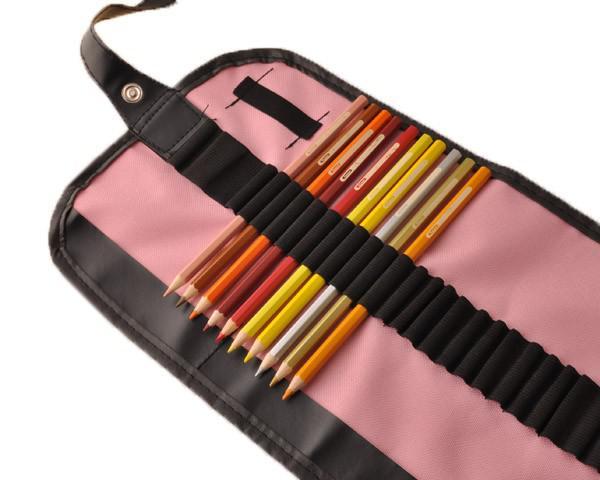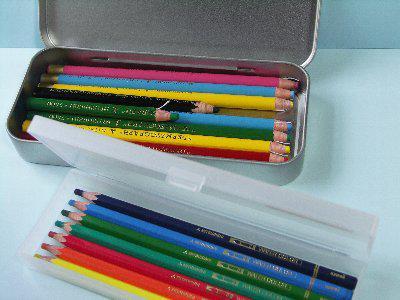The first image is the image on the left, the second image is the image on the right. Examine the images to the left and right. Is the description "The pencils in the image on the left are laying with their points facing down and slightly left." accurate? Answer yes or no. Yes. The first image is the image on the left, the second image is the image on the right. For the images displayed, is the sentence "Some of the pencils are in a case made of metal." factually correct? Answer yes or no. Yes. 